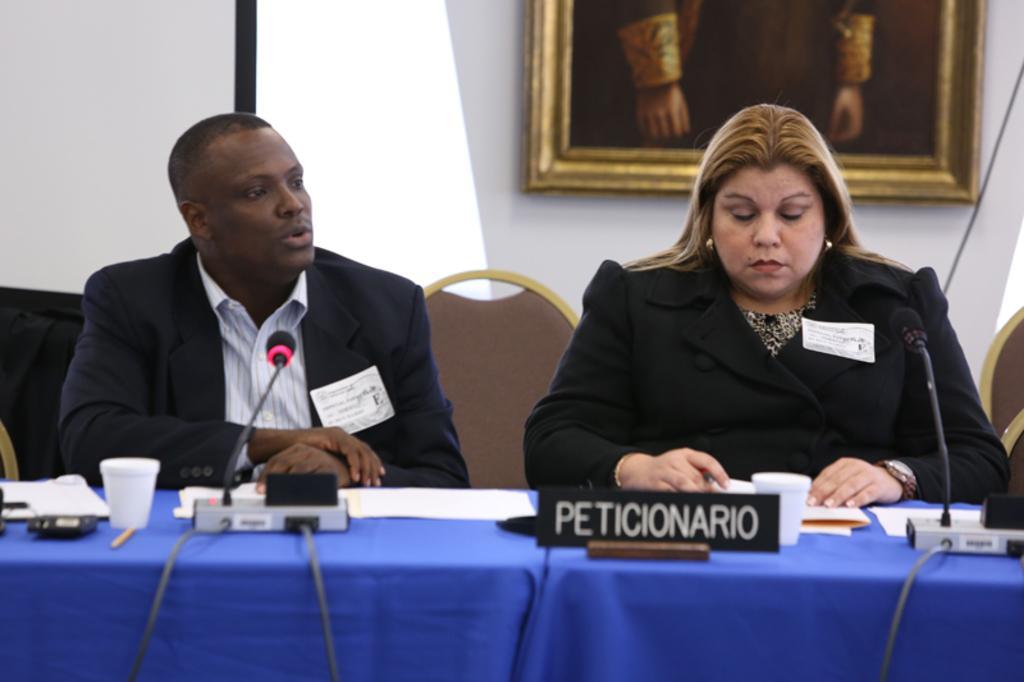Describe this image in one or two sentences. There is a woman in black color coat sitting on a chair near a person who is in black color suit sitting on a chair and is speaking in front of a table on which, there are mice arranged, white color cups,documents and other objects. In the background, there is a photo frame on the white wall. 